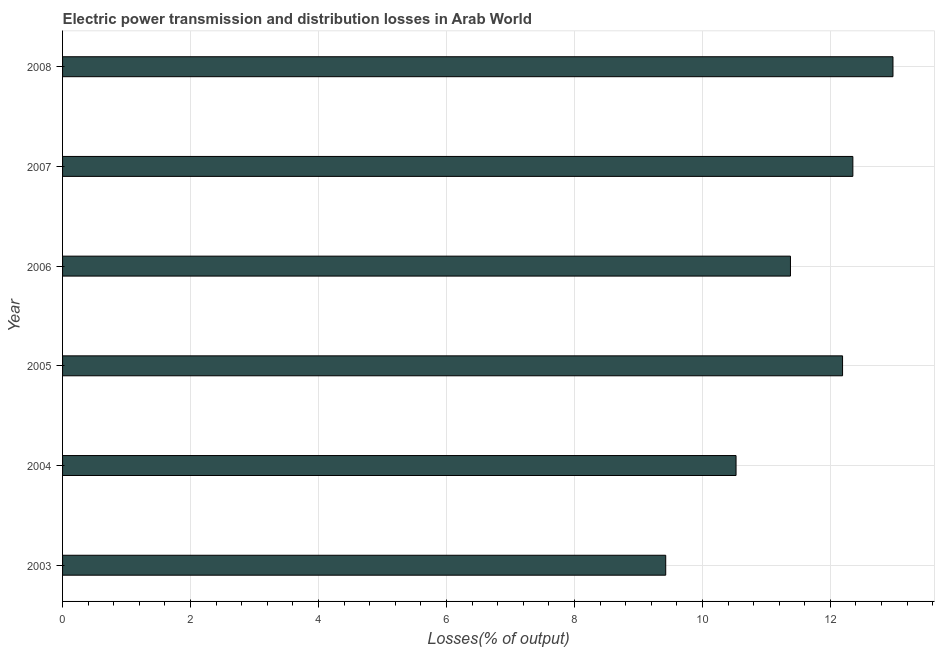Does the graph contain any zero values?
Your answer should be compact. No. What is the title of the graph?
Your answer should be very brief. Electric power transmission and distribution losses in Arab World. What is the label or title of the X-axis?
Your answer should be very brief. Losses(% of output). What is the label or title of the Y-axis?
Make the answer very short. Year. What is the electric power transmission and distribution losses in 2008?
Ensure brevity in your answer.  12.98. Across all years, what is the maximum electric power transmission and distribution losses?
Your answer should be very brief. 12.98. Across all years, what is the minimum electric power transmission and distribution losses?
Your answer should be very brief. 9.43. In which year was the electric power transmission and distribution losses maximum?
Your answer should be compact. 2008. What is the sum of the electric power transmission and distribution losses?
Your response must be concise. 68.85. What is the difference between the electric power transmission and distribution losses in 2006 and 2008?
Ensure brevity in your answer.  -1.6. What is the average electric power transmission and distribution losses per year?
Keep it short and to the point. 11.47. What is the median electric power transmission and distribution losses?
Ensure brevity in your answer.  11.78. Do a majority of the years between 2008 and 2004 (inclusive) have electric power transmission and distribution losses greater than 12 %?
Your response must be concise. Yes. What is the ratio of the electric power transmission and distribution losses in 2006 to that in 2008?
Your answer should be compact. 0.88. Is the electric power transmission and distribution losses in 2003 less than that in 2007?
Offer a terse response. Yes. Is the difference between the electric power transmission and distribution losses in 2007 and 2008 greater than the difference between any two years?
Ensure brevity in your answer.  No. What is the difference between the highest and the second highest electric power transmission and distribution losses?
Offer a terse response. 0.63. Is the sum of the electric power transmission and distribution losses in 2004 and 2005 greater than the maximum electric power transmission and distribution losses across all years?
Offer a very short reply. Yes. What is the difference between the highest and the lowest electric power transmission and distribution losses?
Your response must be concise. 3.55. How many bars are there?
Keep it short and to the point. 6. Are all the bars in the graph horizontal?
Make the answer very short. Yes. What is the difference between two consecutive major ticks on the X-axis?
Offer a terse response. 2. What is the Losses(% of output) in 2003?
Your answer should be very brief. 9.43. What is the Losses(% of output) of 2004?
Ensure brevity in your answer.  10.53. What is the Losses(% of output) of 2005?
Your answer should be compact. 12.19. What is the Losses(% of output) in 2006?
Offer a terse response. 11.38. What is the Losses(% of output) of 2007?
Provide a short and direct response. 12.35. What is the Losses(% of output) in 2008?
Your response must be concise. 12.98. What is the difference between the Losses(% of output) in 2003 and 2004?
Your answer should be very brief. -1.1. What is the difference between the Losses(% of output) in 2003 and 2005?
Your response must be concise. -2.76. What is the difference between the Losses(% of output) in 2003 and 2006?
Make the answer very short. -1.95. What is the difference between the Losses(% of output) in 2003 and 2007?
Offer a terse response. -2.92. What is the difference between the Losses(% of output) in 2003 and 2008?
Ensure brevity in your answer.  -3.55. What is the difference between the Losses(% of output) in 2004 and 2005?
Give a very brief answer. -1.66. What is the difference between the Losses(% of output) in 2004 and 2006?
Provide a succinct answer. -0.85. What is the difference between the Losses(% of output) in 2004 and 2007?
Offer a terse response. -1.83. What is the difference between the Losses(% of output) in 2004 and 2008?
Provide a short and direct response. -2.45. What is the difference between the Losses(% of output) in 2005 and 2006?
Your answer should be compact. 0.81. What is the difference between the Losses(% of output) in 2005 and 2007?
Provide a succinct answer. -0.16. What is the difference between the Losses(% of output) in 2005 and 2008?
Your answer should be compact. -0.79. What is the difference between the Losses(% of output) in 2006 and 2007?
Give a very brief answer. -0.98. What is the difference between the Losses(% of output) in 2006 and 2008?
Offer a terse response. -1.6. What is the difference between the Losses(% of output) in 2007 and 2008?
Ensure brevity in your answer.  -0.63. What is the ratio of the Losses(% of output) in 2003 to that in 2004?
Give a very brief answer. 0.9. What is the ratio of the Losses(% of output) in 2003 to that in 2005?
Make the answer very short. 0.77. What is the ratio of the Losses(% of output) in 2003 to that in 2006?
Ensure brevity in your answer.  0.83. What is the ratio of the Losses(% of output) in 2003 to that in 2007?
Your answer should be very brief. 0.76. What is the ratio of the Losses(% of output) in 2003 to that in 2008?
Keep it short and to the point. 0.73. What is the ratio of the Losses(% of output) in 2004 to that in 2005?
Keep it short and to the point. 0.86. What is the ratio of the Losses(% of output) in 2004 to that in 2006?
Keep it short and to the point. 0.93. What is the ratio of the Losses(% of output) in 2004 to that in 2007?
Keep it short and to the point. 0.85. What is the ratio of the Losses(% of output) in 2004 to that in 2008?
Give a very brief answer. 0.81. What is the ratio of the Losses(% of output) in 2005 to that in 2006?
Offer a very short reply. 1.07. What is the ratio of the Losses(% of output) in 2005 to that in 2008?
Ensure brevity in your answer.  0.94. What is the ratio of the Losses(% of output) in 2006 to that in 2007?
Your answer should be compact. 0.92. What is the ratio of the Losses(% of output) in 2006 to that in 2008?
Provide a short and direct response. 0.88. 